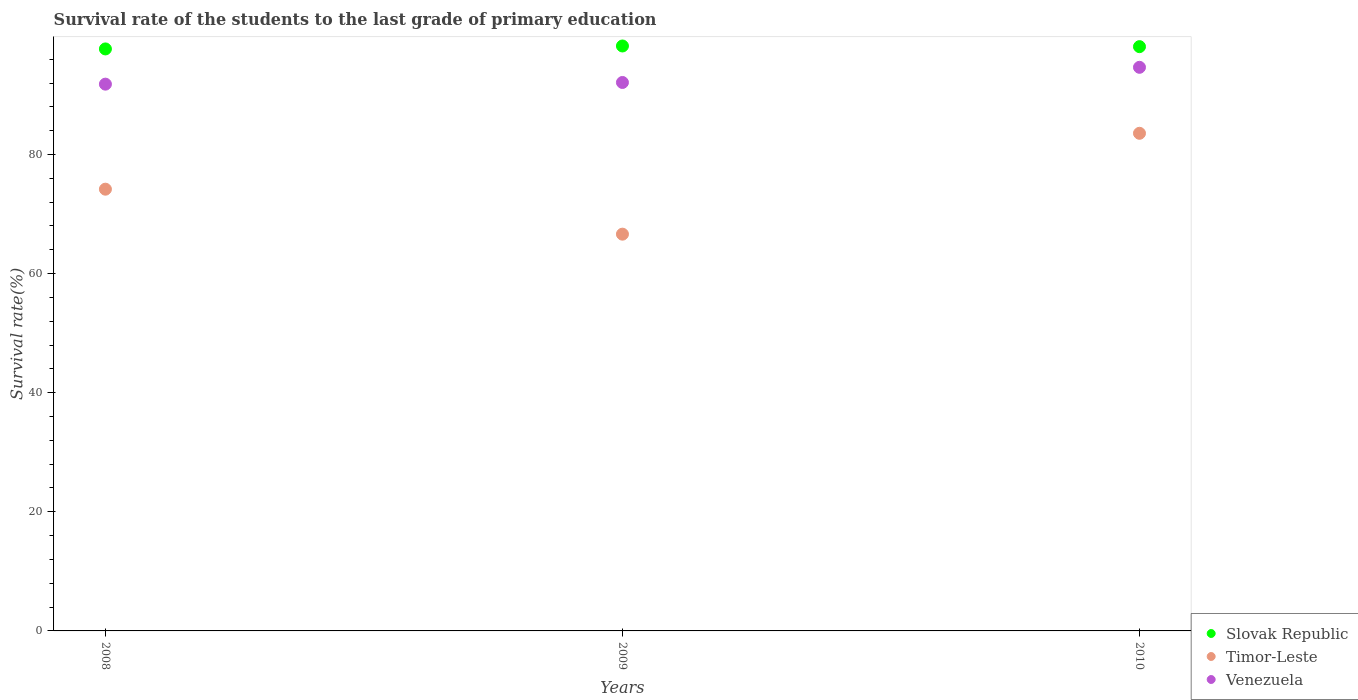How many different coloured dotlines are there?
Offer a very short reply. 3. Is the number of dotlines equal to the number of legend labels?
Your response must be concise. Yes. What is the survival rate of the students in Slovak Republic in 2009?
Keep it short and to the point. 98.22. Across all years, what is the maximum survival rate of the students in Venezuela?
Make the answer very short. 94.64. Across all years, what is the minimum survival rate of the students in Venezuela?
Your response must be concise. 91.81. What is the total survival rate of the students in Slovak Republic in the graph?
Your answer should be very brief. 294.05. What is the difference between the survival rate of the students in Slovak Republic in 2009 and that in 2010?
Your answer should be very brief. 0.11. What is the difference between the survival rate of the students in Timor-Leste in 2009 and the survival rate of the students in Venezuela in 2010?
Make the answer very short. -28.02. What is the average survival rate of the students in Venezuela per year?
Your answer should be compact. 92.85. In the year 2009, what is the difference between the survival rate of the students in Venezuela and survival rate of the students in Slovak Republic?
Provide a short and direct response. -6.13. What is the ratio of the survival rate of the students in Timor-Leste in 2008 to that in 2010?
Make the answer very short. 0.89. Is the survival rate of the students in Timor-Leste in 2008 less than that in 2010?
Provide a succinct answer. Yes. What is the difference between the highest and the second highest survival rate of the students in Timor-Leste?
Offer a terse response. 9.38. What is the difference between the highest and the lowest survival rate of the students in Venezuela?
Offer a terse response. 2.83. In how many years, is the survival rate of the students in Timor-Leste greater than the average survival rate of the students in Timor-Leste taken over all years?
Give a very brief answer. 1. Is the sum of the survival rate of the students in Timor-Leste in 2008 and 2010 greater than the maximum survival rate of the students in Slovak Republic across all years?
Provide a succinct answer. Yes. Does the survival rate of the students in Timor-Leste monotonically increase over the years?
Provide a short and direct response. No. How many dotlines are there?
Your response must be concise. 3. What is the difference between two consecutive major ticks on the Y-axis?
Give a very brief answer. 20. Are the values on the major ticks of Y-axis written in scientific E-notation?
Keep it short and to the point. No. Does the graph contain any zero values?
Provide a short and direct response. No. Does the graph contain grids?
Give a very brief answer. No. Where does the legend appear in the graph?
Give a very brief answer. Bottom right. What is the title of the graph?
Offer a terse response. Survival rate of the students to the last grade of primary education. What is the label or title of the Y-axis?
Your response must be concise. Survival rate(%). What is the Survival rate(%) of Slovak Republic in 2008?
Ensure brevity in your answer.  97.72. What is the Survival rate(%) in Timor-Leste in 2008?
Offer a very short reply. 74.17. What is the Survival rate(%) in Venezuela in 2008?
Make the answer very short. 91.81. What is the Survival rate(%) in Slovak Republic in 2009?
Offer a very short reply. 98.22. What is the Survival rate(%) in Timor-Leste in 2009?
Offer a very short reply. 66.62. What is the Survival rate(%) in Venezuela in 2009?
Keep it short and to the point. 92.09. What is the Survival rate(%) in Slovak Republic in 2010?
Offer a very short reply. 98.11. What is the Survival rate(%) in Timor-Leste in 2010?
Your response must be concise. 83.56. What is the Survival rate(%) of Venezuela in 2010?
Provide a short and direct response. 94.64. Across all years, what is the maximum Survival rate(%) of Slovak Republic?
Keep it short and to the point. 98.22. Across all years, what is the maximum Survival rate(%) in Timor-Leste?
Your response must be concise. 83.56. Across all years, what is the maximum Survival rate(%) of Venezuela?
Provide a succinct answer. 94.64. Across all years, what is the minimum Survival rate(%) of Slovak Republic?
Offer a very short reply. 97.72. Across all years, what is the minimum Survival rate(%) of Timor-Leste?
Keep it short and to the point. 66.62. Across all years, what is the minimum Survival rate(%) in Venezuela?
Your response must be concise. 91.81. What is the total Survival rate(%) in Slovak Republic in the graph?
Provide a succinct answer. 294.05. What is the total Survival rate(%) in Timor-Leste in the graph?
Provide a succinct answer. 224.36. What is the total Survival rate(%) in Venezuela in the graph?
Offer a very short reply. 278.54. What is the difference between the Survival rate(%) of Slovak Republic in 2008 and that in 2009?
Your answer should be very brief. -0.49. What is the difference between the Survival rate(%) in Timor-Leste in 2008 and that in 2009?
Provide a short and direct response. 7.55. What is the difference between the Survival rate(%) in Venezuela in 2008 and that in 2009?
Your response must be concise. -0.28. What is the difference between the Survival rate(%) in Slovak Republic in 2008 and that in 2010?
Offer a very short reply. -0.38. What is the difference between the Survival rate(%) in Timor-Leste in 2008 and that in 2010?
Ensure brevity in your answer.  -9.38. What is the difference between the Survival rate(%) of Venezuela in 2008 and that in 2010?
Offer a very short reply. -2.83. What is the difference between the Survival rate(%) of Slovak Republic in 2009 and that in 2010?
Make the answer very short. 0.11. What is the difference between the Survival rate(%) in Timor-Leste in 2009 and that in 2010?
Make the answer very short. -16.94. What is the difference between the Survival rate(%) in Venezuela in 2009 and that in 2010?
Make the answer very short. -2.55. What is the difference between the Survival rate(%) of Slovak Republic in 2008 and the Survival rate(%) of Timor-Leste in 2009?
Keep it short and to the point. 31.1. What is the difference between the Survival rate(%) of Slovak Republic in 2008 and the Survival rate(%) of Venezuela in 2009?
Make the answer very short. 5.63. What is the difference between the Survival rate(%) of Timor-Leste in 2008 and the Survival rate(%) of Venezuela in 2009?
Provide a succinct answer. -17.92. What is the difference between the Survival rate(%) in Slovak Republic in 2008 and the Survival rate(%) in Timor-Leste in 2010?
Provide a succinct answer. 14.17. What is the difference between the Survival rate(%) of Slovak Republic in 2008 and the Survival rate(%) of Venezuela in 2010?
Offer a very short reply. 3.09. What is the difference between the Survival rate(%) in Timor-Leste in 2008 and the Survival rate(%) in Venezuela in 2010?
Provide a succinct answer. -20.46. What is the difference between the Survival rate(%) of Slovak Republic in 2009 and the Survival rate(%) of Timor-Leste in 2010?
Your answer should be compact. 14.66. What is the difference between the Survival rate(%) of Slovak Republic in 2009 and the Survival rate(%) of Venezuela in 2010?
Keep it short and to the point. 3.58. What is the difference between the Survival rate(%) in Timor-Leste in 2009 and the Survival rate(%) in Venezuela in 2010?
Your answer should be compact. -28.02. What is the average Survival rate(%) in Slovak Republic per year?
Provide a succinct answer. 98.02. What is the average Survival rate(%) in Timor-Leste per year?
Your response must be concise. 74.79. What is the average Survival rate(%) in Venezuela per year?
Provide a short and direct response. 92.85. In the year 2008, what is the difference between the Survival rate(%) of Slovak Republic and Survival rate(%) of Timor-Leste?
Offer a terse response. 23.55. In the year 2008, what is the difference between the Survival rate(%) of Slovak Republic and Survival rate(%) of Venezuela?
Offer a very short reply. 5.91. In the year 2008, what is the difference between the Survival rate(%) of Timor-Leste and Survival rate(%) of Venezuela?
Offer a very short reply. -17.64. In the year 2009, what is the difference between the Survival rate(%) of Slovak Republic and Survival rate(%) of Timor-Leste?
Give a very brief answer. 31.6. In the year 2009, what is the difference between the Survival rate(%) in Slovak Republic and Survival rate(%) in Venezuela?
Your response must be concise. 6.13. In the year 2009, what is the difference between the Survival rate(%) in Timor-Leste and Survival rate(%) in Venezuela?
Your answer should be very brief. -25.47. In the year 2010, what is the difference between the Survival rate(%) in Slovak Republic and Survival rate(%) in Timor-Leste?
Offer a very short reply. 14.55. In the year 2010, what is the difference between the Survival rate(%) of Slovak Republic and Survival rate(%) of Venezuela?
Your answer should be very brief. 3.47. In the year 2010, what is the difference between the Survival rate(%) in Timor-Leste and Survival rate(%) in Venezuela?
Provide a short and direct response. -11.08. What is the ratio of the Survival rate(%) in Slovak Republic in 2008 to that in 2009?
Keep it short and to the point. 0.99. What is the ratio of the Survival rate(%) of Timor-Leste in 2008 to that in 2009?
Offer a very short reply. 1.11. What is the ratio of the Survival rate(%) of Venezuela in 2008 to that in 2009?
Offer a very short reply. 1. What is the ratio of the Survival rate(%) in Slovak Republic in 2008 to that in 2010?
Your answer should be very brief. 1. What is the ratio of the Survival rate(%) of Timor-Leste in 2008 to that in 2010?
Provide a succinct answer. 0.89. What is the ratio of the Survival rate(%) of Venezuela in 2008 to that in 2010?
Your response must be concise. 0.97. What is the ratio of the Survival rate(%) in Timor-Leste in 2009 to that in 2010?
Keep it short and to the point. 0.8. What is the ratio of the Survival rate(%) in Venezuela in 2009 to that in 2010?
Make the answer very short. 0.97. What is the difference between the highest and the second highest Survival rate(%) in Slovak Republic?
Provide a short and direct response. 0.11. What is the difference between the highest and the second highest Survival rate(%) in Timor-Leste?
Provide a short and direct response. 9.38. What is the difference between the highest and the second highest Survival rate(%) in Venezuela?
Provide a succinct answer. 2.55. What is the difference between the highest and the lowest Survival rate(%) in Slovak Republic?
Provide a succinct answer. 0.49. What is the difference between the highest and the lowest Survival rate(%) of Timor-Leste?
Your response must be concise. 16.94. What is the difference between the highest and the lowest Survival rate(%) in Venezuela?
Your response must be concise. 2.83. 